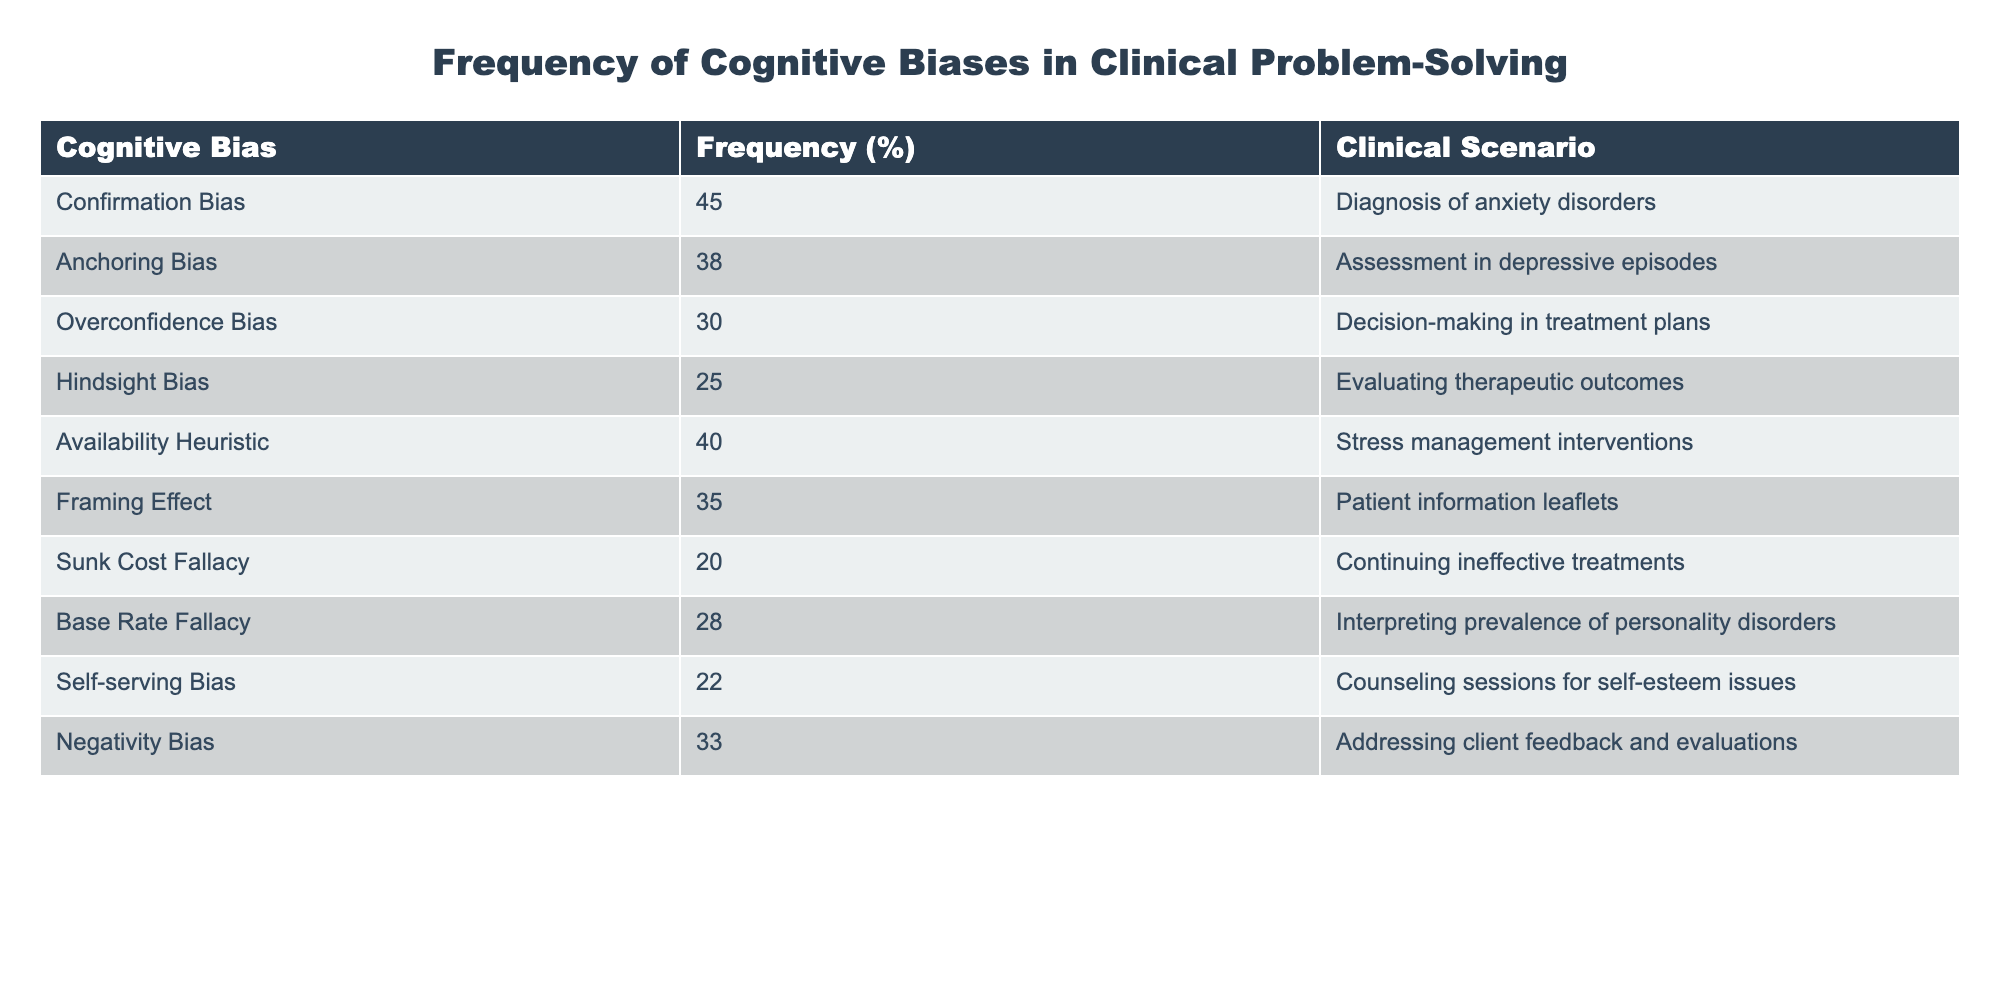What is the frequency of Confirmation Bias encountered in clinical scenarios? The table lists the frequency of various cognitive biases. For Confirmation Bias, the entry shows 45% under the frequency column.
Answer: 45% Which cognitive bias has the lowest frequency in the table? By inspecting the frequency column, Sunk Cost Fallacy is noted with a frequency of 20%, which is the lowest compared to other biases.
Answer: Sunk Cost Fallacy What is the average frequency of the cognitive biases listed in the table? The frequencies are: 45, 38, 30, 25, 40, 35, 20, 28, 22, 33. Summing these gives: 45 + 38 + 30 + 25 + 40 + 35 + 20 + 28 + 22 + 33 =  366. There are 10 data points, so the average frequency is 366 / 10 = 36.6.
Answer: 36.6 Is the frequency of Overconfidence Bias higher than that of Framing Effect? The frequency for Overconfidence Bias is 30% and for Framing Effect it is 35%. Since 30 is less than 35, the statement is false.
Answer: No Which cognitive bias is associated with the diagnosis of anxiety disorders? The table indicates that Confirmation Bias (45%) is associated with the diagnosis of anxiety disorders, as shown in the corresponding row.
Answer: Confirmation Bias What is the total frequency of biases related to patient information leaflets and continuing ineffective treatments? The frequency for Framing Effect (related to patient information leaflets) is 35% and for Sunk Cost Fallacy (related to continuing ineffective treatments) is 20%. Adding these frequencies gives 35 + 20 = 55%.
Answer: 55% How many cognitive biases have a frequency above 30% in the table? The biases with frequencies above 30% are: Confirmation Bias (45%), Anchoring Bias (38%), Availability Heuristic (40%), Negativity Bias (33%), and Framing Effect (35%). This gives a total of 5 biases.
Answer: 5 Is it true that the Availability Heuristic is encountered more frequently than the Base Rate Fallacy? The Availability Heuristic has a frequency of 40%, while the Base Rate Fallacy has a frequency of 28%. Since 40 is greater than 28, the statement is true.
Answer: Yes What is the difference in frequency between the highest and lowest cognitive biases? The highest frequency is 45% (Confirmation Bias) and the lowest is 20% (Sunk Cost Fallacy). The difference is 45 - 20 = 25%.
Answer: 25% 